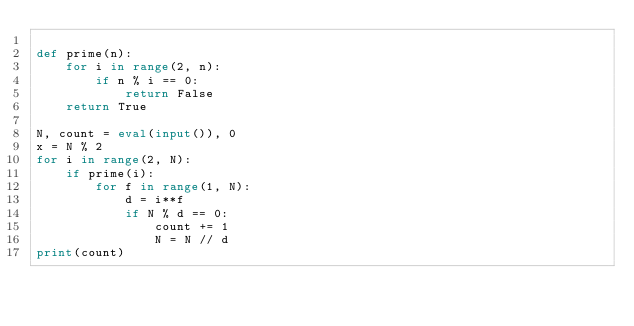<code> <loc_0><loc_0><loc_500><loc_500><_Python_>
def prime(n):
    for i in range(2, n):
        if n % i == 0:
            return False
    return True

N, count = eval(input()), 0
x = N % 2
for i in range(2, N):
    if prime(i):
        for f in range(1, N):
            d = i**f
            if N % d == 0:
                count += 1
                N = N // d
print(count)
</code> 